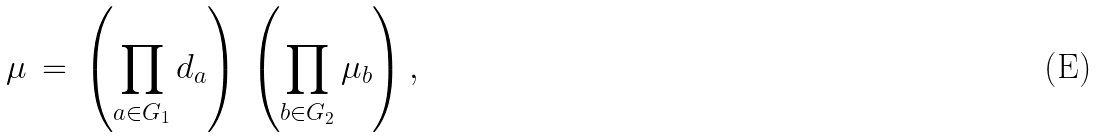Convert formula to latex. <formula><loc_0><loc_0><loc_500><loc_500>\mu \, = \, \left ( \prod _ { a \in G _ { 1 } } d _ { a } \right ) \, \left ( \prod _ { b \in G _ { 2 } } \mu _ { b } \right ) ,</formula> 